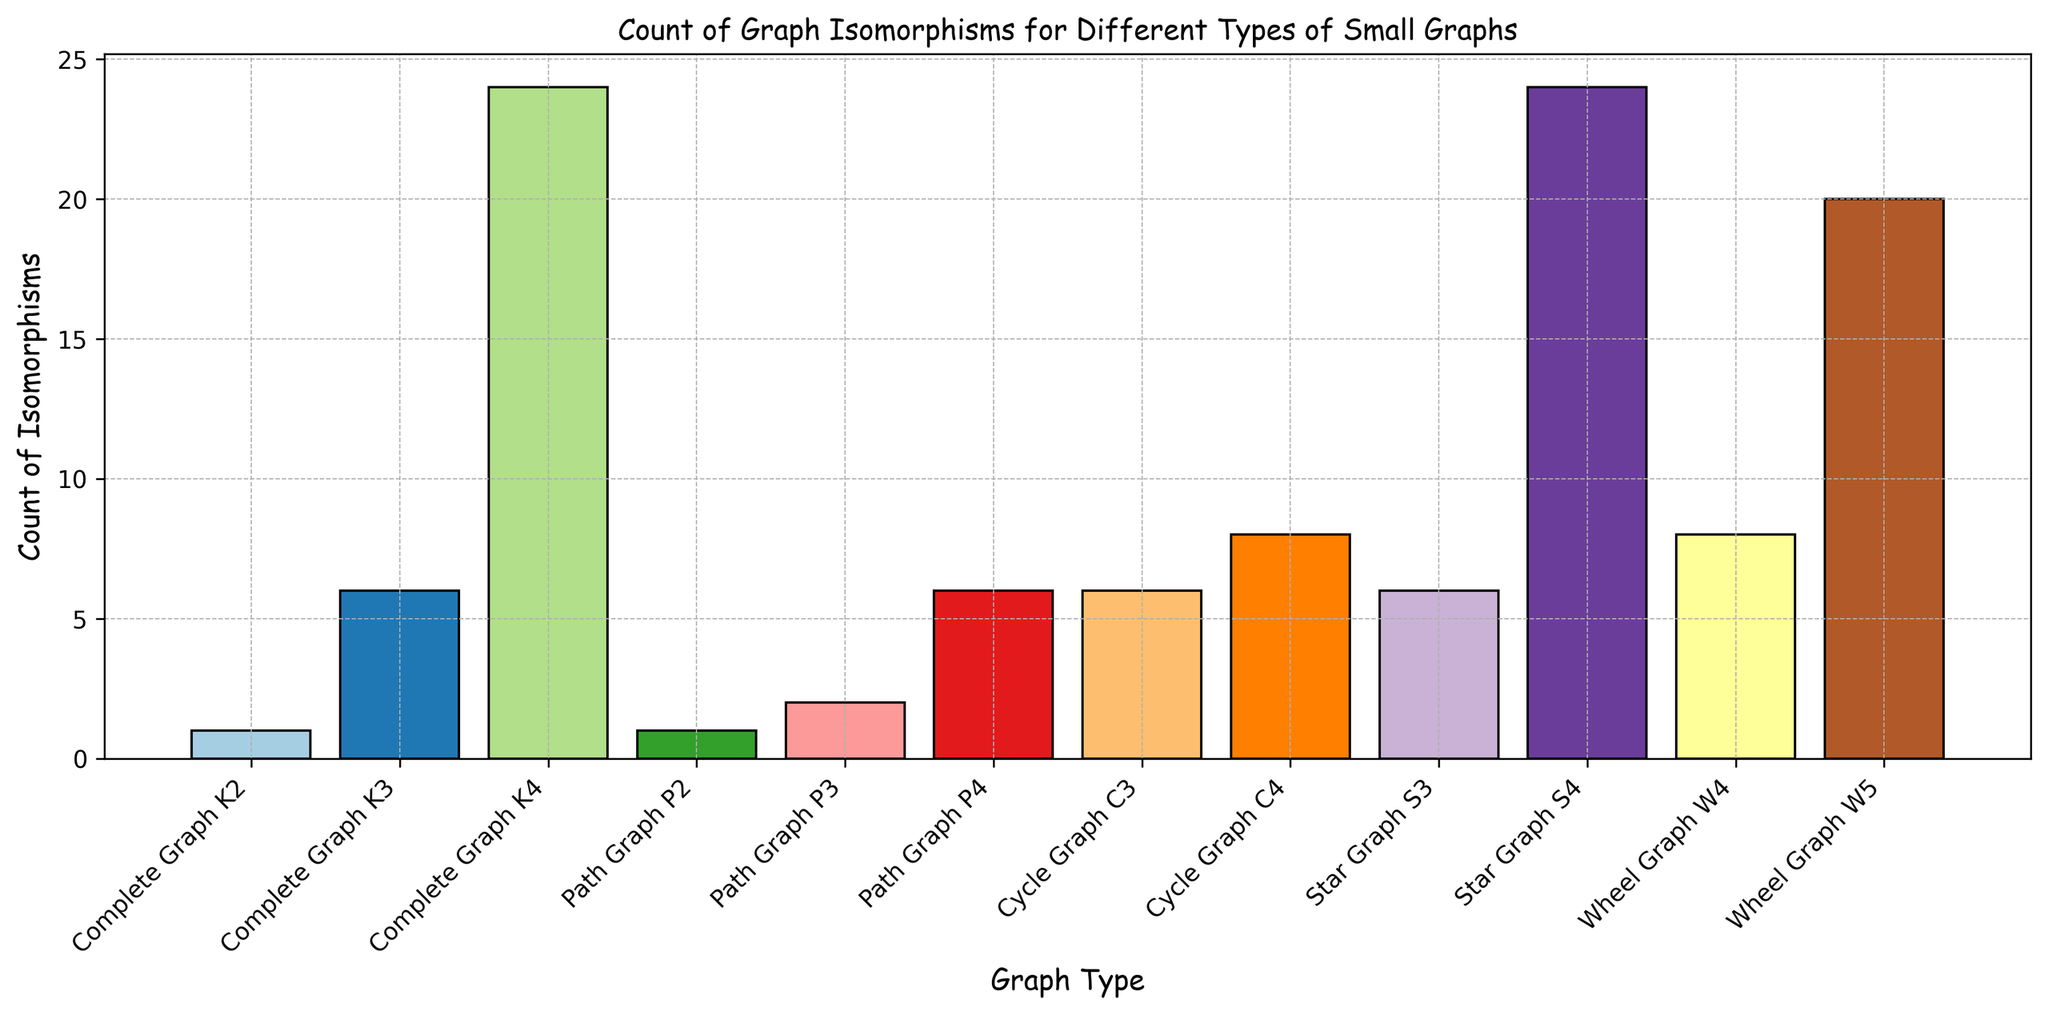What is the graph type with the highest count of isomorphisms? By looking at the height of the bars, we can see the tallest bar represents "Complete Graph K4" and "Star Graph S4" with counts of 24 isomorphisms.
Answer: Complete Graph K4 and Star Graph S4 Which graph types have the fewest count of isomorphisms? Observing the shortest bars, the graph types "Complete Graph K2" and "Path Graph P2" both have the count of isomorphisms as 1.
Answer: Complete Graph K2 and Path Graph P2 How many graph types have a count of isomorphisms greater than 10? Counting the bars that are taller than the threshold corresponding to 10 on the y-axis, we identify "Complete Graph K4," "Star Graph S4," and "Wheel Graph W5" having counts of isomorphisms greater than 10.
Answer: 3 What is the difference in the count of isomorphisms between Cycle Graph C3 and Cycle Graph C4? From the chart, Cycle Graph C3 has 6 isomorphisms and Cycle Graph C4 has 8 isomorphisms. The difference is 8 - 6.
Answer: 2 What is the average number of isomorphisms for Complete Graph K3, Star Graph S3, and Wheel Graph W4? Summing the counts for these graph types: 6 (K3) + 6 (S3) + 8 (W4) = 20, then dividing by the number of graph types, which is 3 gives 20 / 3.
Answer: 6.67 Which graph type among Path graphs (P2, P3, P4) has the highest count of isomorphisms? Among Path graphs, by comparing the heights of the bars, we observe that Path Graph P4 has the highest count of isomorphisms, which is 6.
Answer: Path Graph P4 What is the total count of isomorphisms for all types of graphs combined? Summing up all the values from the graph: 1 + 6 + 24 + 1 + 2 + 6 + 6 + 8 + 6 + 24 + 8 + 20 = 112.
Answer: 112 Which graph type has the same count of isomorphisms as Cycle Graph C3? Both Cycle Graph C3 and Star Graph S3 have a count of isomorphisms of 6, as seen from the bars with equal heights in the chart.
Answer: Star Graph S3 Is the number of isomorphisms for Wheel Graph W4 closer to Star Graph S3 or Cycle Graph C4? By comparing the numbers, Wheel Graph W4 has 8 isomorphisms, Star Graph S3 has 6, and Cycle Graph C4 has 8. Hence, W4 (8) is closer in count to Cycle Graph C4 (8) than Star Graph S3 (6).
Answer: Cycle Graph C4 